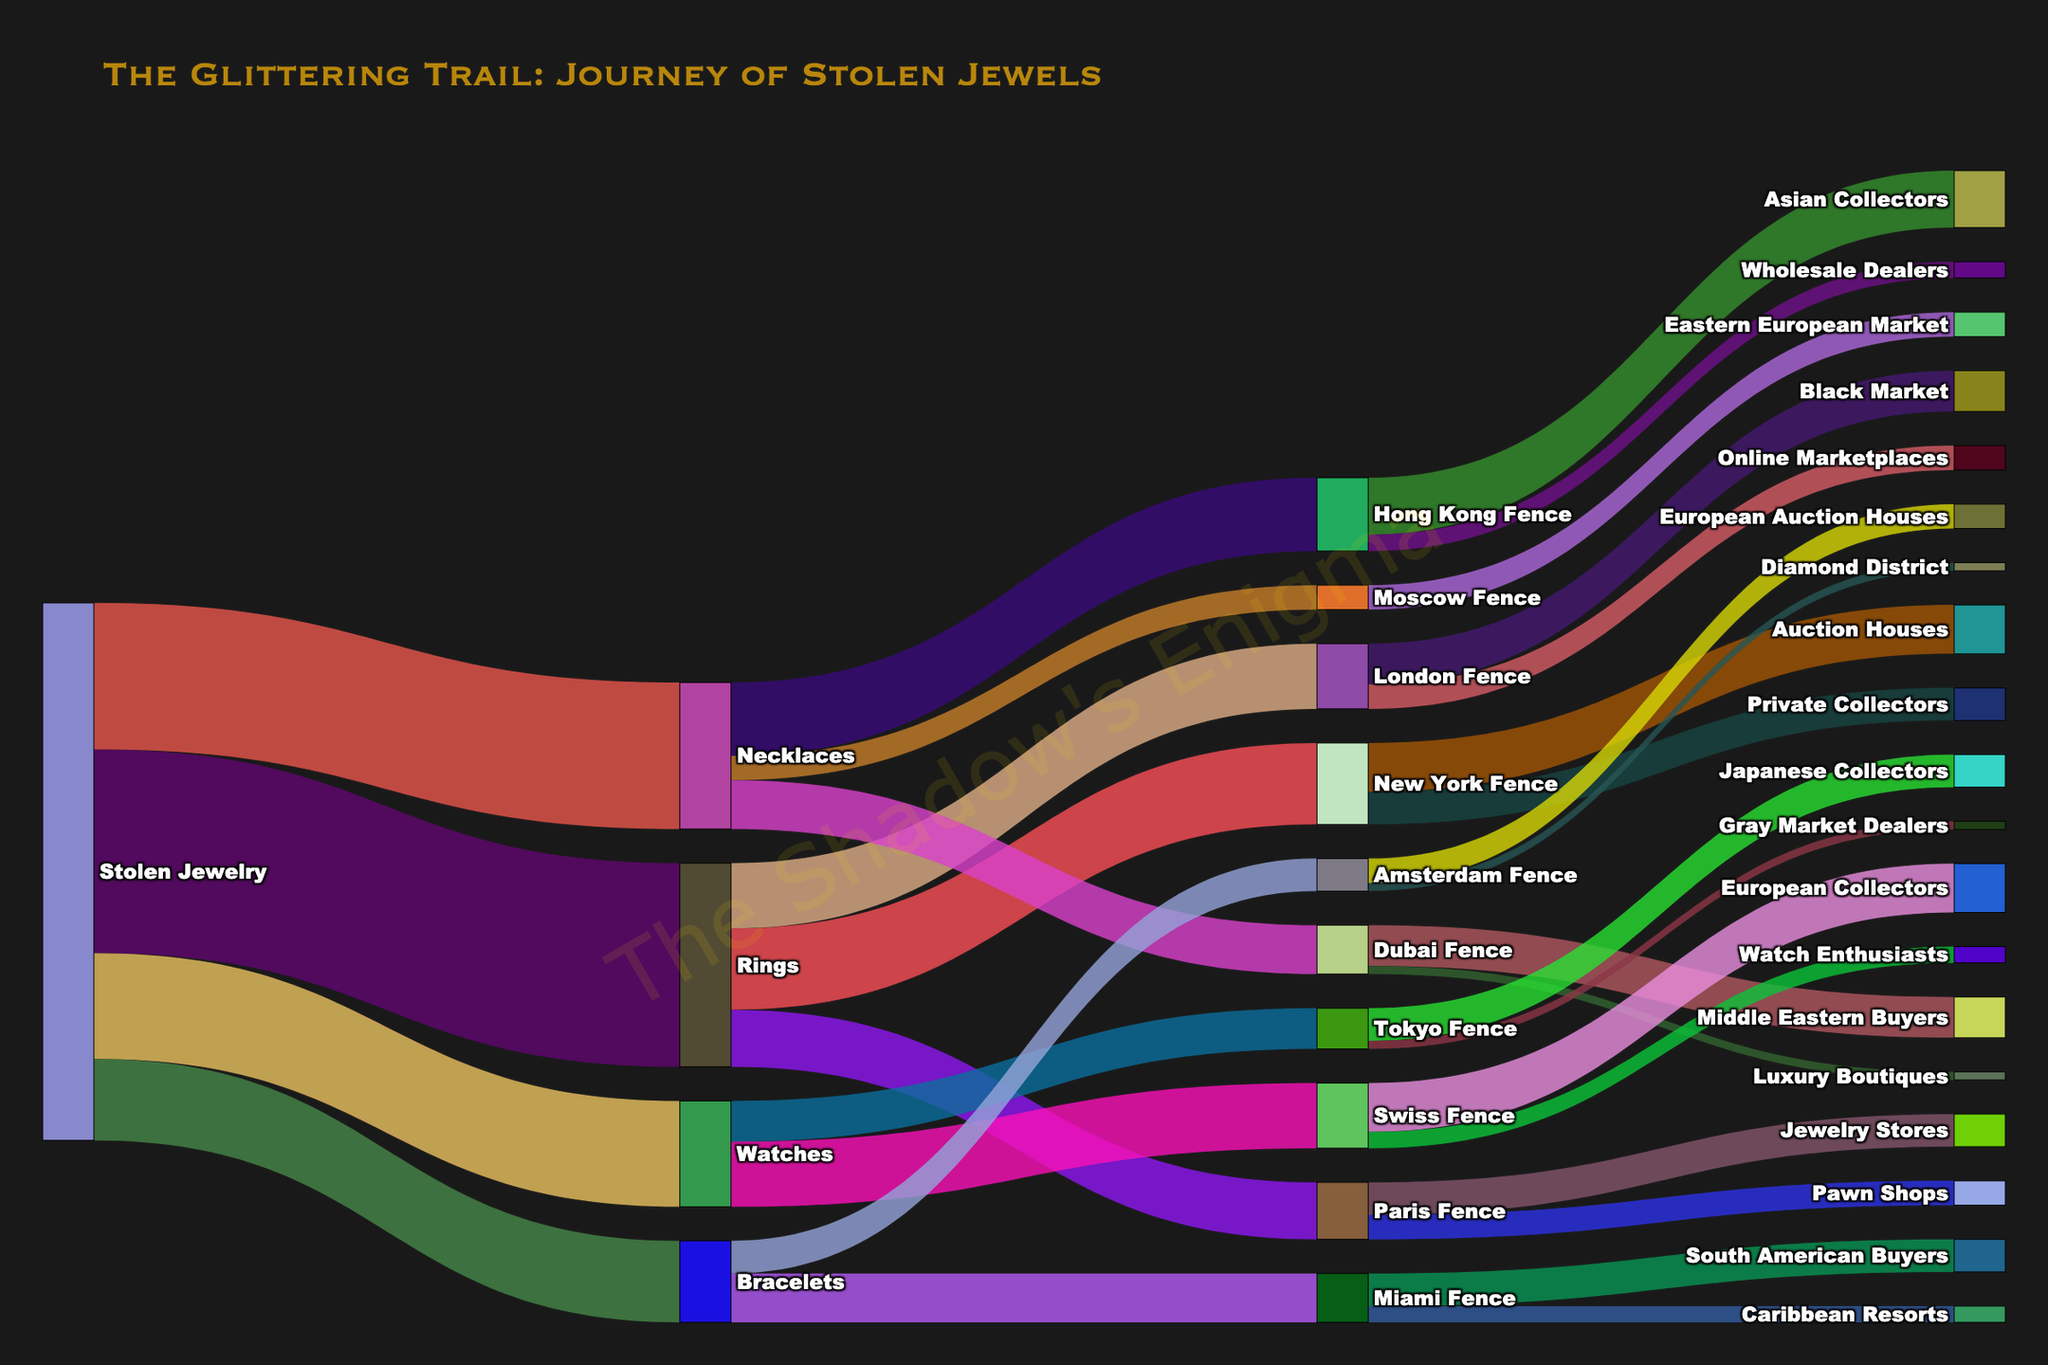Who fences the most stolen rings? To find the fence dealing with the most stolen rings, look at the flows from "Rings." The numbers show that "New York Fence" receives 100 rings, which is the largest amount compared to other fences receiving rings.
Answer: New York Fence Which type of jewelry is most stolen? Check the flows originating from "Stolen Jewelry." The flow to "Rings" is 250, which is the highest value among the different types of jewelry.
Answer: Rings How many stolen necklaces are fenced by the Hong Kong Fence? Look at the flow from "Necklaces" to "Hong Kong Fence." The value is 90.
Answer: 90 Which destination received the least stolen jewelry from the London Fence? Look at the flows originating from "London Fence." The flow to "Online Marketplaces" is 30, which is less than the 50 going to the "Black Market."
Answer: Online Marketplaces What's the total amount of stolen jewelry that ends up with private collectors? Identify the flows to "Private Collectors," which only comes from "New York Fence" with a value of 40. The total is therefore 40.
Answer: 40 Which fence deals with the smallest amount of stolen watches? Check the flows from "Watches" to various fences. "Tokyo Fence" gets 50 watches, which is less than the 80 received by the "Swiss Fence."
Answer: Tokyo Fence How many pieces of stolen jewelry are eventually handled by European collectors, whether from watches or other types? Determine the flow to "European Collectors" from fences. Only "Swiss Fence" sends 60, from watches. Therefore, the total is 60.
Answer: 60 What's the combined value of stolen jewels fenced through Hong Kong and Dubai? Sum the values of flows to "Hong Kong Fence" (90 from necklaces) and "Dubai Fence" (60 from necklaces). The result is 90 + 60 = 150.
Answer: 150 